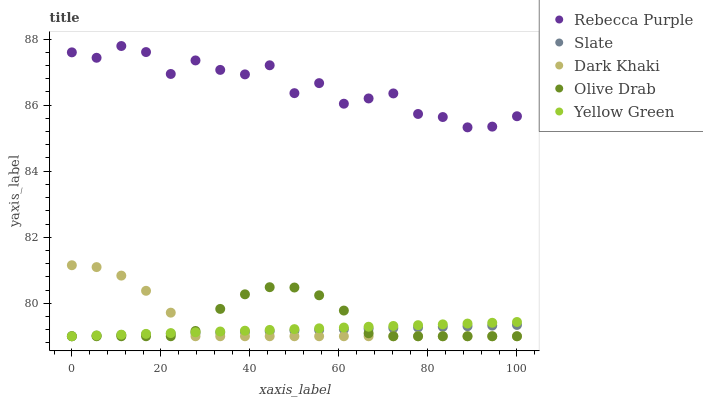Does Slate have the minimum area under the curve?
Answer yes or no. Yes. Does Rebecca Purple have the maximum area under the curve?
Answer yes or no. Yes. Does Rebecca Purple have the minimum area under the curve?
Answer yes or no. No. Does Slate have the maximum area under the curve?
Answer yes or no. No. Is Slate the smoothest?
Answer yes or no. Yes. Is Rebecca Purple the roughest?
Answer yes or no. Yes. Is Rebecca Purple the smoothest?
Answer yes or no. No. Is Slate the roughest?
Answer yes or no. No. Does Dark Khaki have the lowest value?
Answer yes or no. Yes. Does Rebecca Purple have the lowest value?
Answer yes or no. No. Does Rebecca Purple have the highest value?
Answer yes or no. Yes. Does Slate have the highest value?
Answer yes or no. No. Is Slate less than Rebecca Purple?
Answer yes or no. Yes. Is Rebecca Purple greater than Olive Drab?
Answer yes or no. Yes. Does Olive Drab intersect Yellow Green?
Answer yes or no. Yes. Is Olive Drab less than Yellow Green?
Answer yes or no. No. Is Olive Drab greater than Yellow Green?
Answer yes or no. No. Does Slate intersect Rebecca Purple?
Answer yes or no. No. 